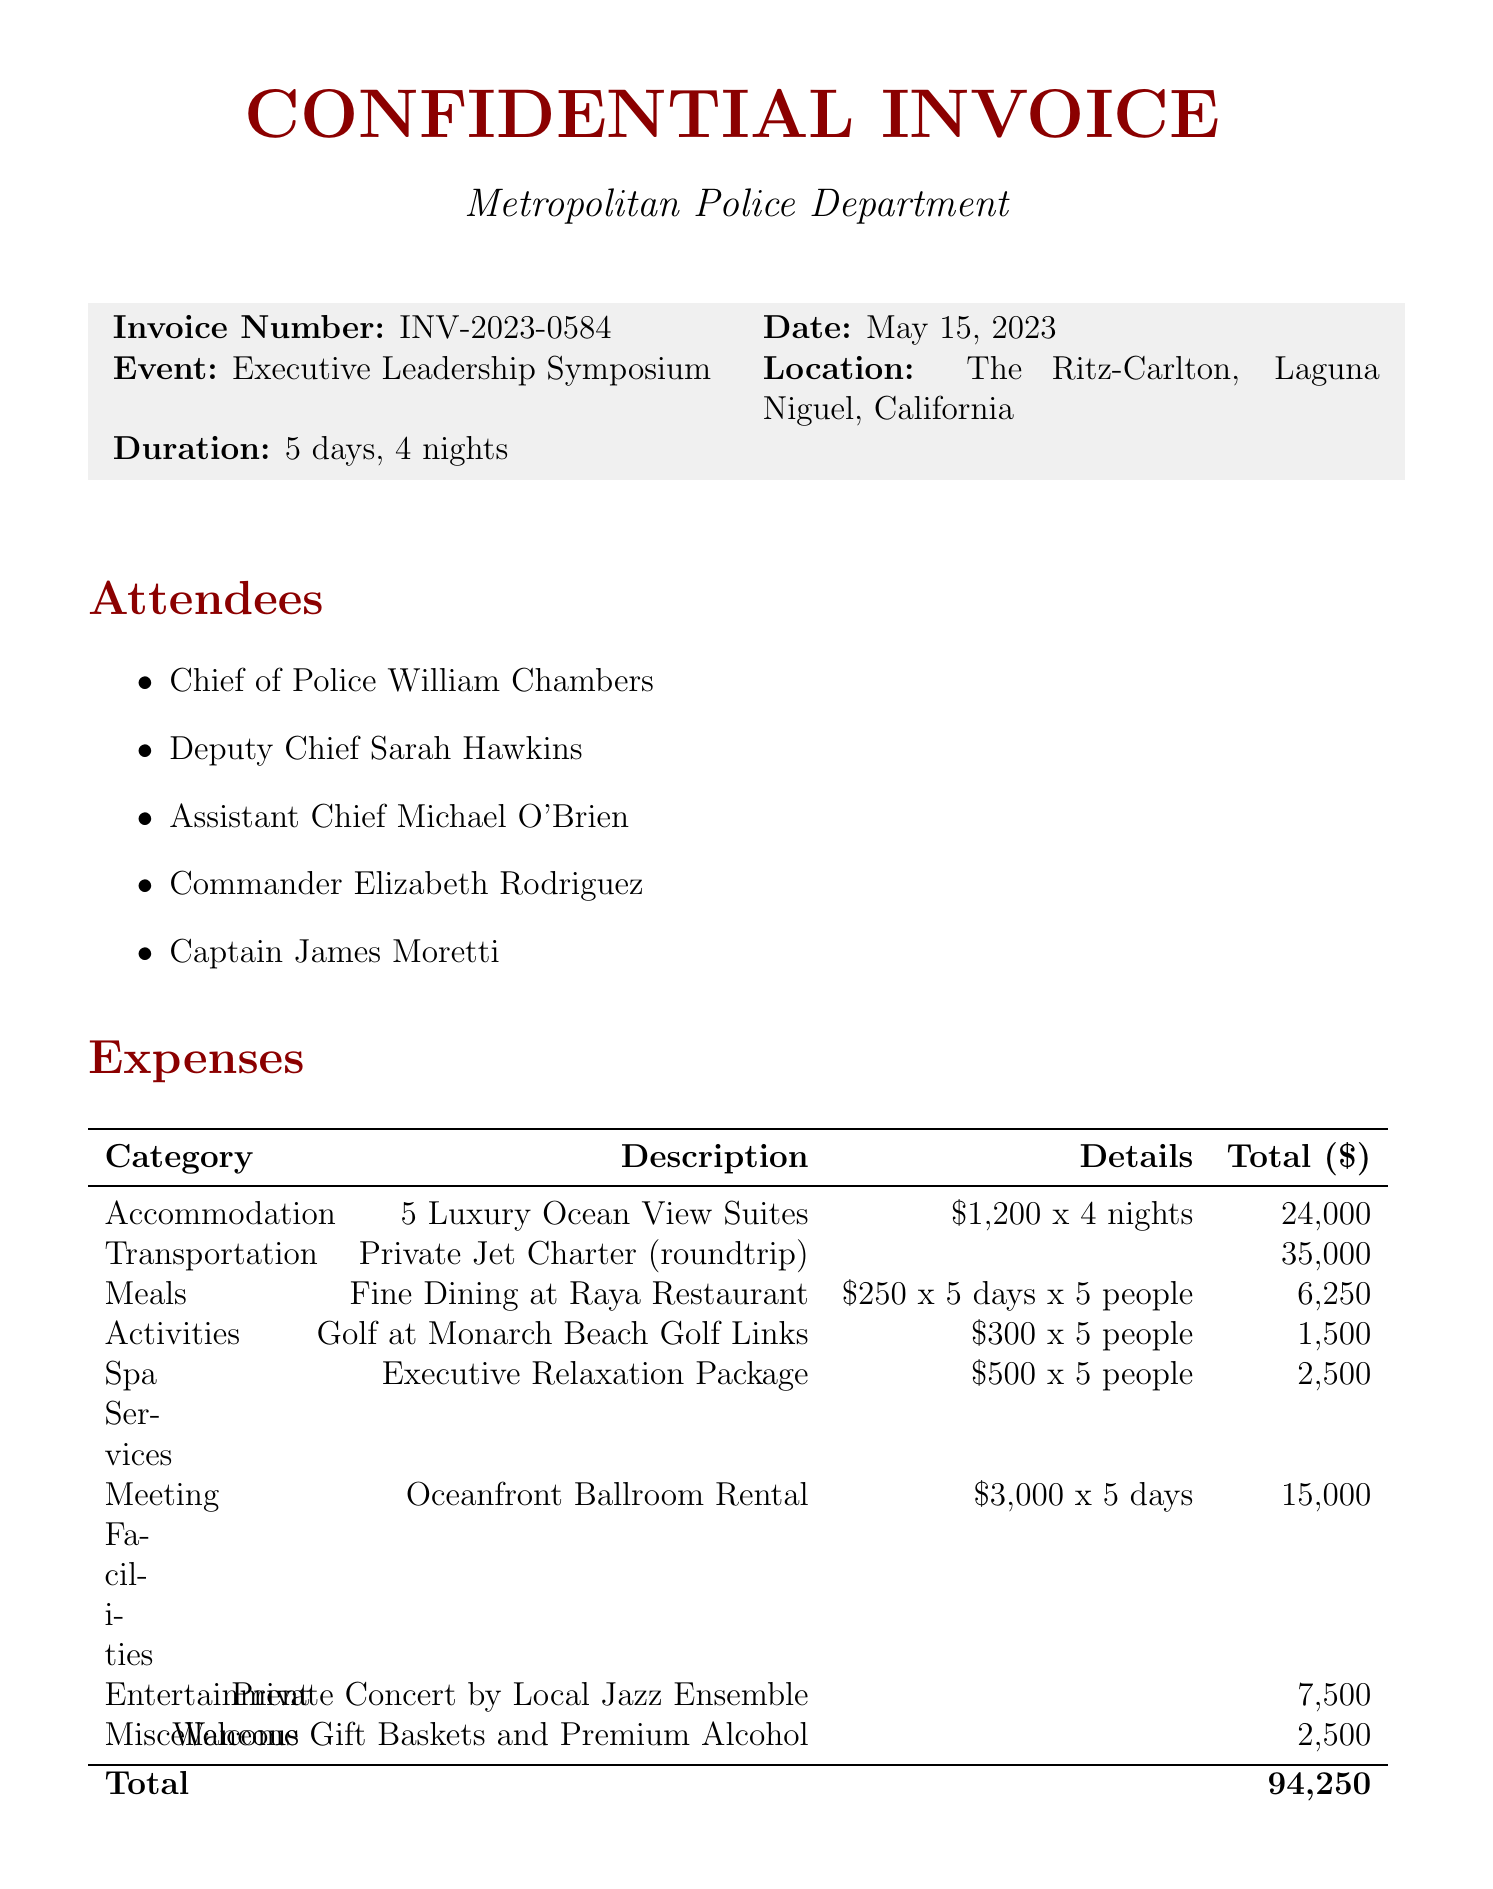what is the invoice number? The invoice number is explicitly listed in the document as a unique identifier for this transaction.
Answer: INV-2023-0584 what is the total amount of expenses? The total amount represents the sum of all expenses incurred during the event.
Answer: 94,250 how many nights did the retreat last? The duration of the event is specified, indicating the total nights spent at the location.
Answer: 4 nights who approved the expenses? The approver’s name is provided as part of the invoice details.
Answer: Mayor Thomas Anderson what category does the private jet charter expense fall under? The expense categories are labeled, categorizing each type of spending for clarity.
Answer: Transportation how many attendees were there in total? The list of attendees is provided, and counting them gives the total number.
Answer: 5 what was the cost per night for the luxury suites? The accommodation cost is detailed, which specifies both the total and per night pricing.
Answer: 1,200 what is the location of the event? The event location is mentioned clearly at the beginning of the invoice details.
Answer: The Ritz-Carlton, Laguna Niguel, California what do the notes classify the event as? The notes provide a classification for the event to justify the expenses incurred.
Answer: Essential Training and Development 